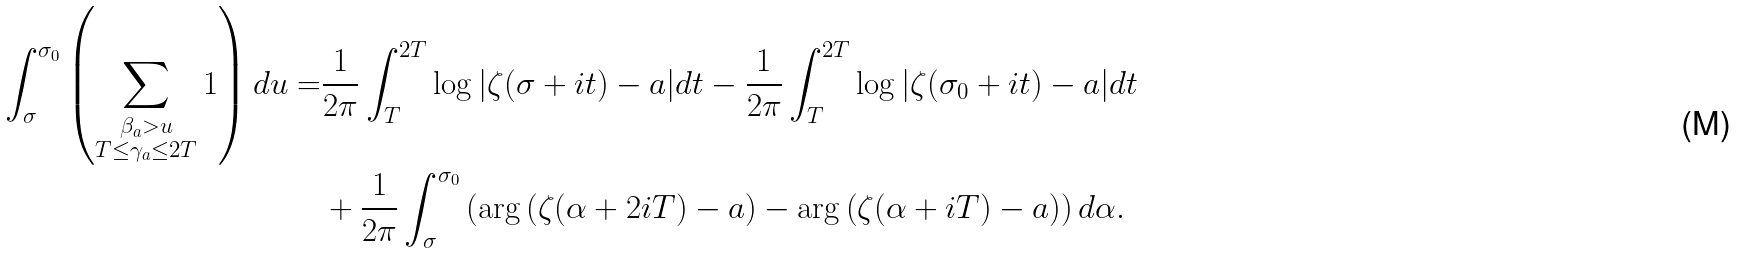<formula> <loc_0><loc_0><loc_500><loc_500>\int _ { \sigma } ^ { \sigma _ { 0 } } \left ( \sum _ { \substack { \beta _ { a } > u \\ T \leq \gamma _ { a } \leq 2 T } } 1 \right ) d u = & \frac { 1 } { 2 \pi } \int _ { T } ^ { 2 T } \log | \zeta ( \sigma + i t ) - a | d t - \frac { 1 } { 2 \pi } \int _ { T } ^ { 2 T } \log | \zeta ( \sigma _ { 0 } + i t ) - a | d t \\ & + \frac { 1 } { 2 \pi } \int _ { \sigma } ^ { \sigma _ { 0 } } \left ( \arg \left ( \zeta ( \alpha + 2 i T ) - a \right ) - \arg \left ( \zeta ( \alpha + i T ) - a \right ) \right ) d \alpha .</formula> 